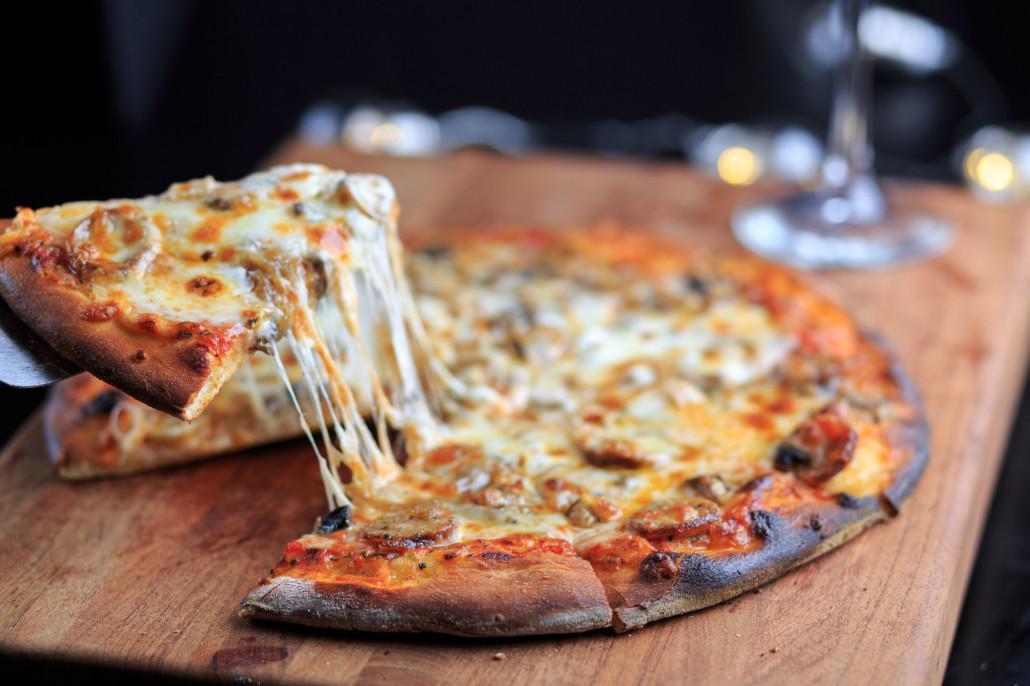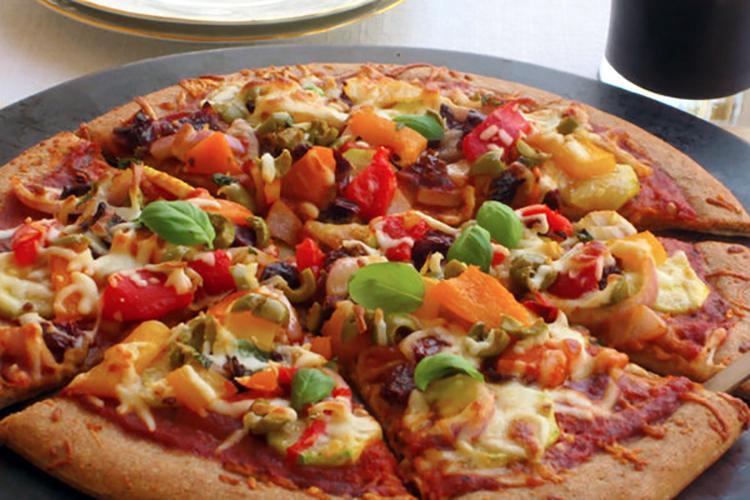The first image is the image on the left, the second image is the image on the right. Analyze the images presented: Is the assertion "There is at least one [basil] leaf on the pizza on the right." valid? Answer yes or no. Yes. The first image is the image on the left, the second image is the image on the right. Assess this claim about the two images: "One of the pizzas is a cheese and pepperoni pizza.". Correct or not? Answer yes or no. No. 